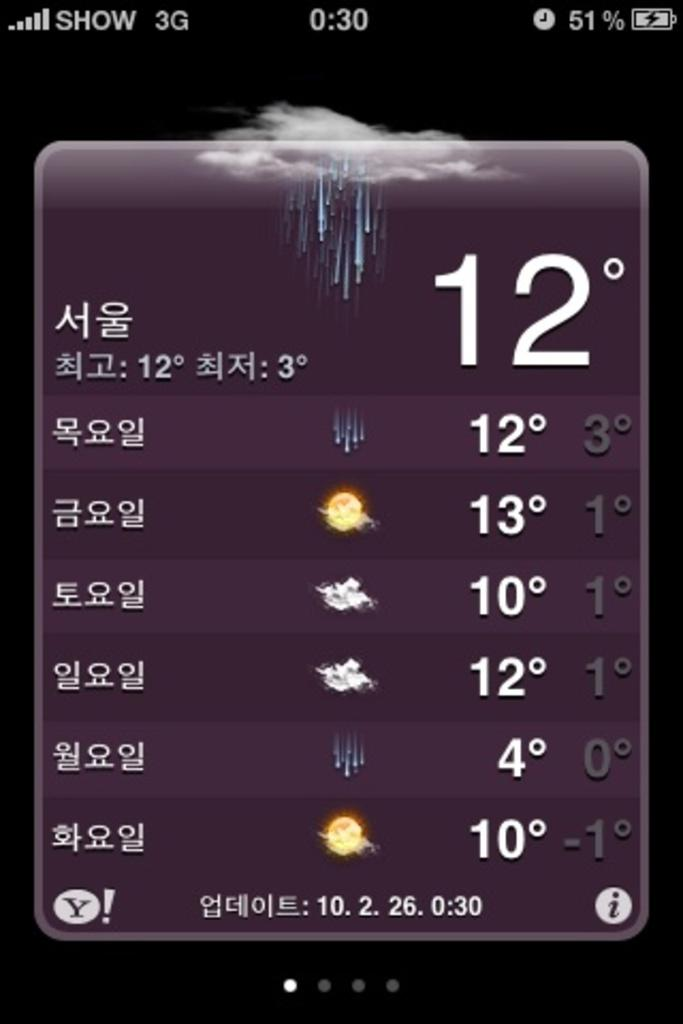<image>
Share a concise interpretation of the image provided. Phone screen showing the temperature at 12 on one day. 